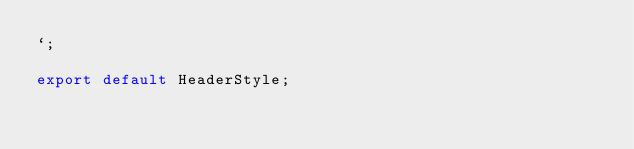Convert code to text. <code><loc_0><loc_0><loc_500><loc_500><_JavaScript_>`;

export default HeaderStyle;</code> 